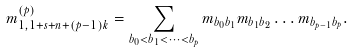Convert formula to latex. <formula><loc_0><loc_0><loc_500><loc_500>m _ { 1 , 1 + s + n + ( p - 1 ) k } ^ { ( p ) } = \sum _ { b _ { 0 } < b _ { 1 } < \dots < b _ { p } } m _ { b _ { 0 } b _ { 1 } } m _ { b _ { 1 } b _ { 2 } } \dots m _ { b _ { p - 1 } b _ { p } } .</formula> 